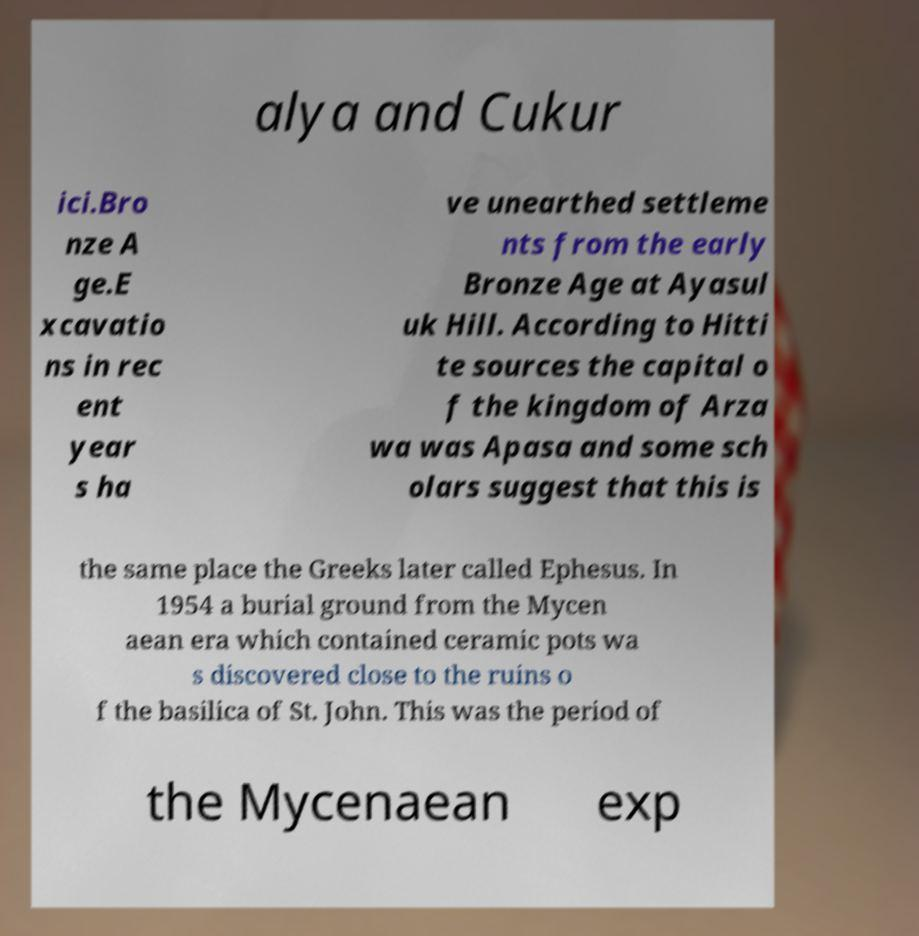For documentation purposes, I need the text within this image transcribed. Could you provide that? alya and Cukur ici.Bro nze A ge.E xcavatio ns in rec ent year s ha ve unearthed settleme nts from the early Bronze Age at Ayasul uk Hill. According to Hitti te sources the capital o f the kingdom of Arza wa was Apasa and some sch olars suggest that this is the same place the Greeks later called Ephesus. In 1954 a burial ground from the Mycen aean era which contained ceramic pots wa s discovered close to the ruins o f the basilica of St. John. This was the period of the Mycenaean exp 